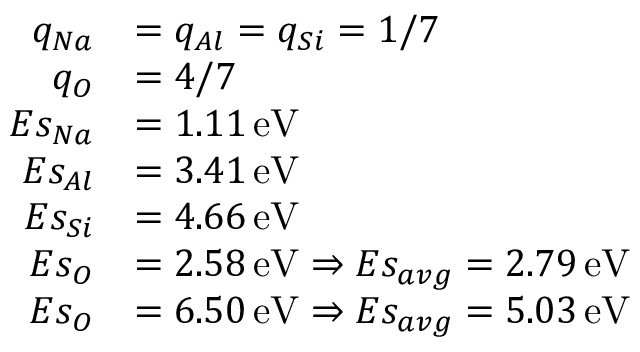<formula> <loc_0><loc_0><loc_500><loc_500>\begin{array} { r l } { q _ { N a } } & { = q _ { A l } = q _ { S i } = 1 / 7 } \\ { q _ { O } } & { = 4 / 7 } \\ { E s _ { N a } } & { = 1 . 1 1 \, e V } \\ { E s _ { A l } } & { = 3 . 4 1 \, e V } \\ { E s _ { S i } } & { = 4 . 6 6 \, e V } \\ { E s _ { O } } & { = 2 . 5 8 \, e V \Rightarrow E s _ { a v g } = 2 . 7 9 \, e V } \\ { E s _ { O } } & { = 6 . 5 0 \, e V \Rightarrow E s _ { a v g } = 5 . 0 3 \, e V } \end{array}</formula> 